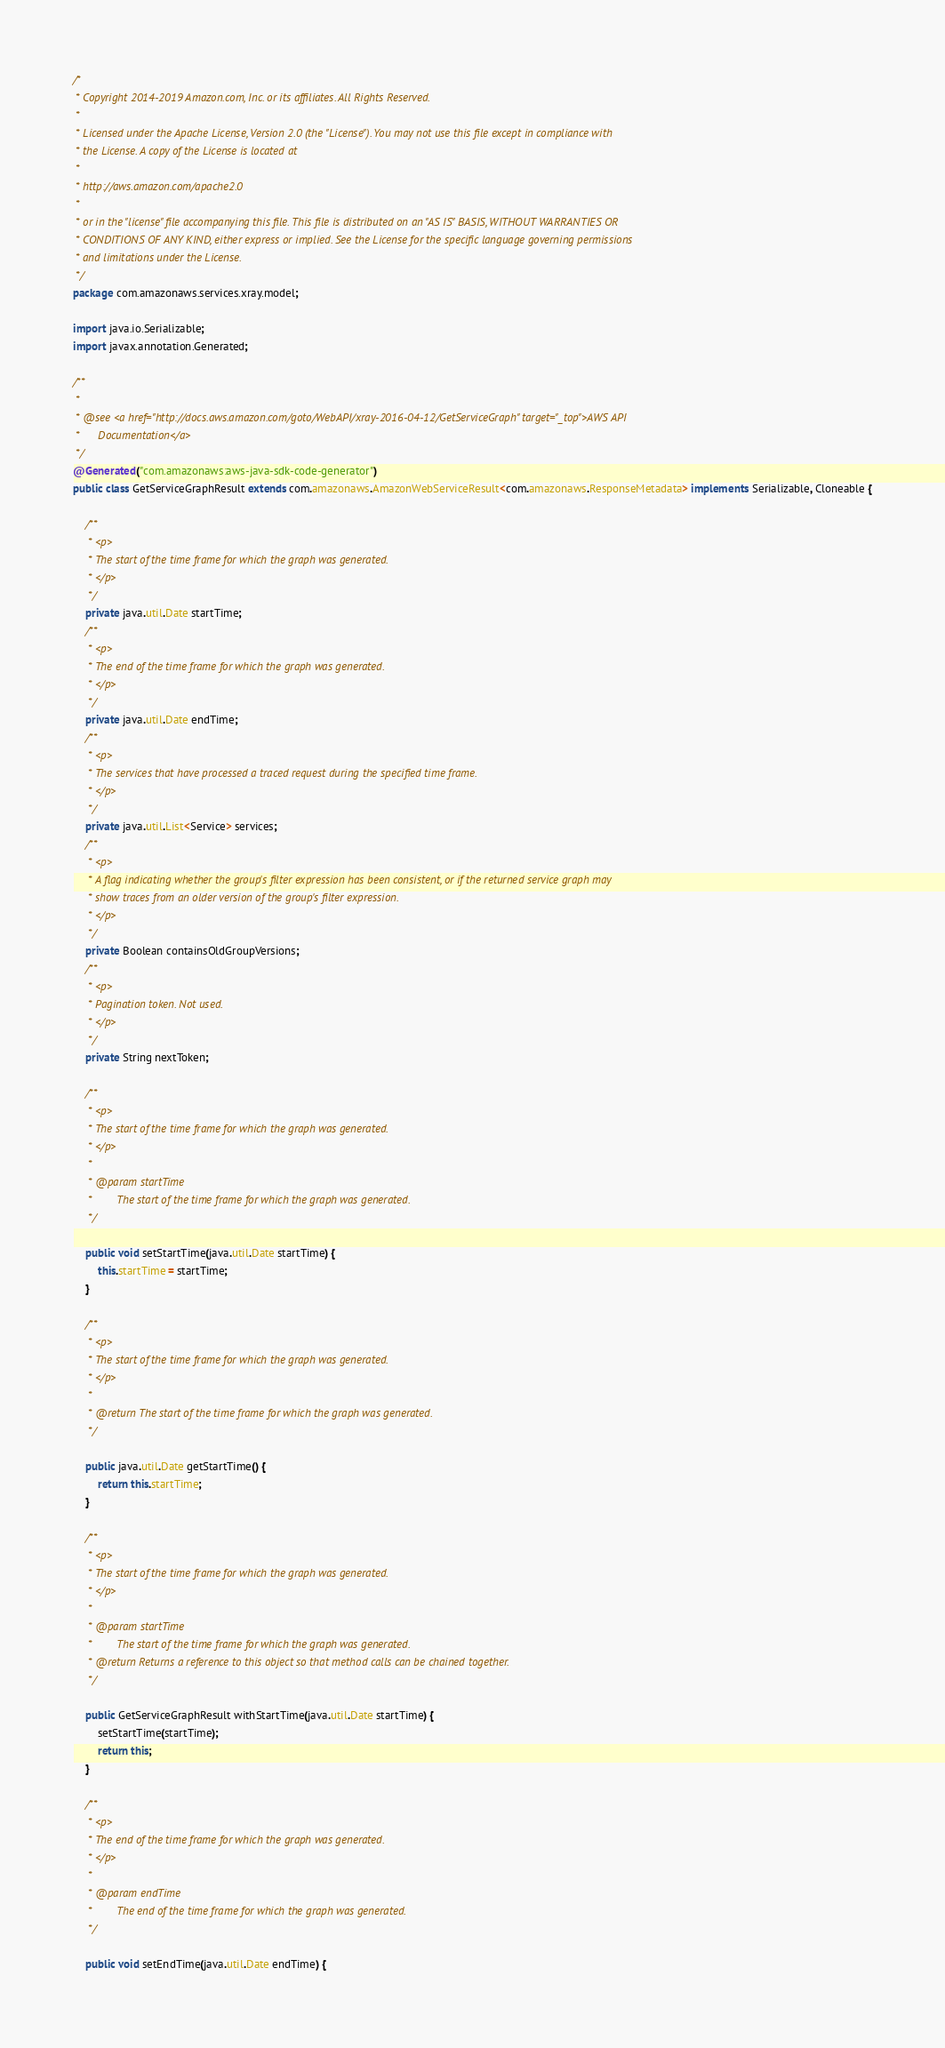Convert code to text. <code><loc_0><loc_0><loc_500><loc_500><_Java_>/*
 * Copyright 2014-2019 Amazon.com, Inc. or its affiliates. All Rights Reserved.
 * 
 * Licensed under the Apache License, Version 2.0 (the "License"). You may not use this file except in compliance with
 * the License. A copy of the License is located at
 * 
 * http://aws.amazon.com/apache2.0
 * 
 * or in the "license" file accompanying this file. This file is distributed on an "AS IS" BASIS, WITHOUT WARRANTIES OR
 * CONDITIONS OF ANY KIND, either express or implied. See the License for the specific language governing permissions
 * and limitations under the License.
 */
package com.amazonaws.services.xray.model;

import java.io.Serializable;
import javax.annotation.Generated;

/**
 * 
 * @see <a href="http://docs.aws.amazon.com/goto/WebAPI/xray-2016-04-12/GetServiceGraph" target="_top">AWS API
 *      Documentation</a>
 */
@Generated("com.amazonaws:aws-java-sdk-code-generator")
public class GetServiceGraphResult extends com.amazonaws.AmazonWebServiceResult<com.amazonaws.ResponseMetadata> implements Serializable, Cloneable {

    /**
     * <p>
     * The start of the time frame for which the graph was generated.
     * </p>
     */
    private java.util.Date startTime;
    /**
     * <p>
     * The end of the time frame for which the graph was generated.
     * </p>
     */
    private java.util.Date endTime;
    /**
     * <p>
     * The services that have processed a traced request during the specified time frame.
     * </p>
     */
    private java.util.List<Service> services;
    /**
     * <p>
     * A flag indicating whether the group's filter expression has been consistent, or if the returned service graph may
     * show traces from an older version of the group's filter expression.
     * </p>
     */
    private Boolean containsOldGroupVersions;
    /**
     * <p>
     * Pagination token. Not used.
     * </p>
     */
    private String nextToken;

    /**
     * <p>
     * The start of the time frame for which the graph was generated.
     * </p>
     * 
     * @param startTime
     *        The start of the time frame for which the graph was generated.
     */

    public void setStartTime(java.util.Date startTime) {
        this.startTime = startTime;
    }

    /**
     * <p>
     * The start of the time frame for which the graph was generated.
     * </p>
     * 
     * @return The start of the time frame for which the graph was generated.
     */

    public java.util.Date getStartTime() {
        return this.startTime;
    }

    /**
     * <p>
     * The start of the time frame for which the graph was generated.
     * </p>
     * 
     * @param startTime
     *        The start of the time frame for which the graph was generated.
     * @return Returns a reference to this object so that method calls can be chained together.
     */

    public GetServiceGraphResult withStartTime(java.util.Date startTime) {
        setStartTime(startTime);
        return this;
    }

    /**
     * <p>
     * The end of the time frame for which the graph was generated.
     * </p>
     * 
     * @param endTime
     *        The end of the time frame for which the graph was generated.
     */

    public void setEndTime(java.util.Date endTime) {</code> 